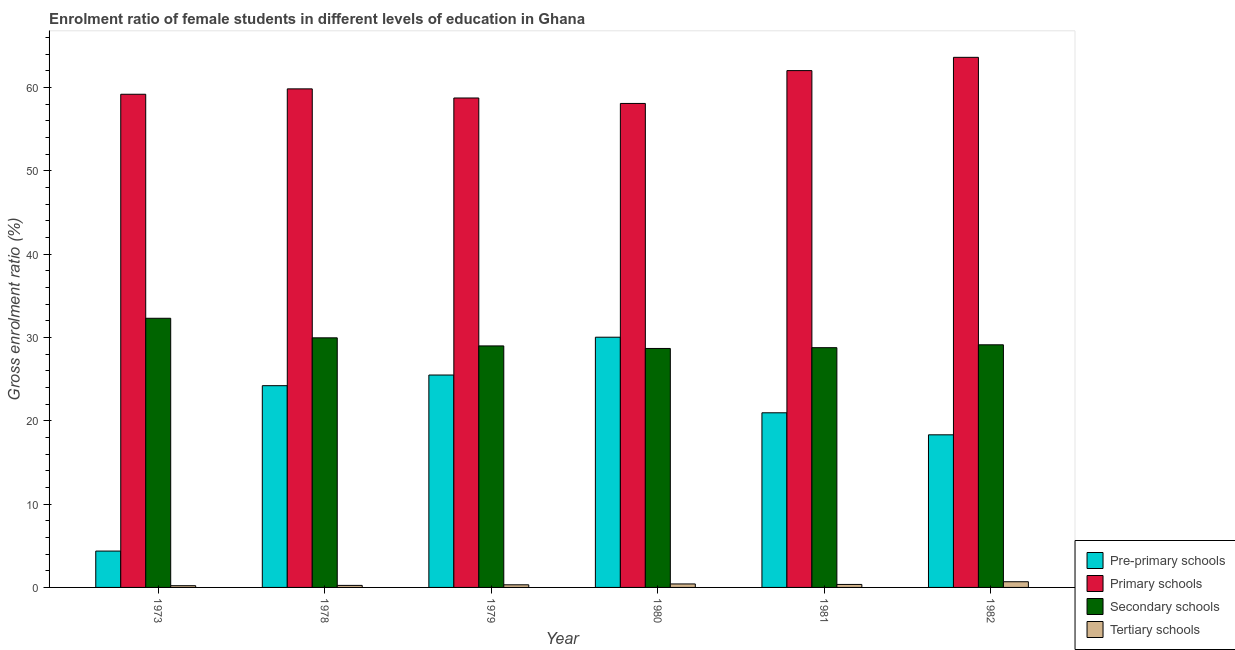Are the number of bars on each tick of the X-axis equal?
Keep it short and to the point. Yes. How many bars are there on the 5th tick from the left?
Offer a terse response. 4. What is the label of the 2nd group of bars from the left?
Provide a short and direct response. 1978. In how many cases, is the number of bars for a given year not equal to the number of legend labels?
Your answer should be very brief. 0. What is the gross enrolment ratio(male) in tertiary schools in 1980?
Your answer should be compact. 0.42. Across all years, what is the maximum gross enrolment ratio(male) in secondary schools?
Provide a succinct answer. 32.31. Across all years, what is the minimum gross enrolment ratio(male) in secondary schools?
Offer a terse response. 28.69. In which year was the gross enrolment ratio(male) in secondary schools maximum?
Give a very brief answer. 1973. In which year was the gross enrolment ratio(male) in pre-primary schools minimum?
Your response must be concise. 1973. What is the total gross enrolment ratio(male) in tertiary schools in the graph?
Make the answer very short. 2.23. What is the difference between the gross enrolment ratio(male) in secondary schools in 1973 and that in 1978?
Make the answer very short. 2.35. What is the difference between the gross enrolment ratio(male) in primary schools in 1982 and the gross enrolment ratio(male) in secondary schools in 1980?
Make the answer very short. 5.54. What is the average gross enrolment ratio(male) in primary schools per year?
Offer a terse response. 60.26. In the year 1982, what is the difference between the gross enrolment ratio(male) in pre-primary schools and gross enrolment ratio(male) in tertiary schools?
Provide a succinct answer. 0. In how many years, is the gross enrolment ratio(male) in primary schools greater than 14 %?
Your answer should be very brief. 6. What is the ratio of the gross enrolment ratio(male) in primary schools in 1973 to that in 1981?
Ensure brevity in your answer.  0.95. Is the gross enrolment ratio(male) in secondary schools in 1973 less than that in 1981?
Provide a short and direct response. No. Is the difference between the gross enrolment ratio(male) in pre-primary schools in 1973 and 1979 greater than the difference between the gross enrolment ratio(male) in tertiary schools in 1973 and 1979?
Keep it short and to the point. No. What is the difference between the highest and the second highest gross enrolment ratio(male) in tertiary schools?
Provide a succinct answer. 0.26. What is the difference between the highest and the lowest gross enrolment ratio(male) in primary schools?
Keep it short and to the point. 5.54. Is it the case that in every year, the sum of the gross enrolment ratio(male) in tertiary schools and gross enrolment ratio(male) in secondary schools is greater than the sum of gross enrolment ratio(male) in pre-primary schools and gross enrolment ratio(male) in primary schools?
Provide a short and direct response. No. What does the 4th bar from the left in 1979 represents?
Your answer should be very brief. Tertiary schools. What does the 2nd bar from the right in 1981 represents?
Ensure brevity in your answer.  Secondary schools. Is it the case that in every year, the sum of the gross enrolment ratio(male) in pre-primary schools and gross enrolment ratio(male) in primary schools is greater than the gross enrolment ratio(male) in secondary schools?
Keep it short and to the point. Yes. How many bars are there?
Ensure brevity in your answer.  24. Are all the bars in the graph horizontal?
Your response must be concise. No. How many years are there in the graph?
Provide a short and direct response. 6. Are the values on the major ticks of Y-axis written in scientific E-notation?
Offer a very short reply. No. Does the graph contain grids?
Provide a succinct answer. No. Where does the legend appear in the graph?
Ensure brevity in your answer.  Bottom right. How many legend labels are there?
Offer a very short reply. 4. How are the legend labels stacked?
Provide a succinct answer. Vertical. What is the title of the graph?
Keep it short and to the point. Enrolment ratio of female students in different levels of education in Ghana. What is the label or title of the X-axis?
Make the answer very short. Year. What is the Gross enrolment ratio (%) of Pre-primary schools in 1973?
Make the answer very short. 4.36. What is the Gross enrolment ratio (%) in Primary schools in 1973?
Offer a very short reply. 59.2. What is the Gross enrolment ratio (%) in Secondary schools in 1973?
Keep it short and to the point. 32.31. What is the Gross enrolment ratio (%) in Tertiary schools in 1973?
Your answer should be very brief. 0.21. What is the Gross enrolment ratio (%) in Pre-primary schools in 1978?
Keep it short and to the point. 24.22. What is the Gross enrolment ratio (%) in Primary schools in 1978?
Your answer should be very brief. 59.85. What is the Gross enrolment ratio (%) of Secondary schools in 1978?
Your answer should be compact. 29.96. What is the Gross enrolment ratio (%) in Tertiary schools in 1978?
Make the answer very short. 0.24. What is the Gross enrolment ratio (%) of Pre-primary schools in 1979?
Make the answer very short. 25.5. What is the Gross enrolment ratio (%) of Primary schools in 1979?
Offer a very short reply. 58.75. What is the Gross enrolment ratio (%) of Secondary schools in 1979?
Offer a very short reply. 28.99. What is the Gross enrolment ratio (%) of Tertiary schools in 1979?
Your answer should be compact. 0.32. What is the Gross enrolment ratio (%) of Pre-primary schools in 1980?
Provide a short and direct response. 30.04. What is the Gross enrolment ratio (%) of Primary schools in 1980?
Keep it short and to the point. 58.1. What is the Gross enrolment ratio (%) of Secondary schools in 1980?
Ensure brevity in your answer.  28.69. What is the Gross enrolment ratio (%) in Tertiary schools in 1980?
Provide a short and direct response. 0.42. What is the Gross enrolment ratio (%) in Pre-primary schools in 1981?
Provide a succinct answer. 20.96. What is the Gross enrolment ratio (%) in Primary schools in 1981?
Offer a very short reply. 62.04. What is the Gross enrolment ratio (%) in Secondary schools in 1981?
Ensure brevity in your answer.  28.78. What is the Gross enrolment ratio (%) of Tertiary schools in 1981?
Your answer should be very brief. 0.36. What is the Gross enrolment ratio (%) of Pre-primary schools in 1982?
Offer a terse response. 18.32. What is the Gross enrolment ratio (%) in Primary schools in 1982?
Your response must be concise. 63.64. What is the Gross enrolment ratio (%) in Secondary schools in 1982?
Offer a very short reply. 29.13. What is the Gross enrolment ratio (%) of Tertiary schools in 1982?
Offer a terse response. 0.68. Across all years, what is the maximum Gross enrolment ratio (%) of Pre-primary schools?
Keep it short and to the point. 30.04. Across all years, what is the maximum Gross enrolment ratio (%) of Primary schools?
Offer a very short reply. 63.64. Across all years, what is the maximum Gross enrolment ratio (%) of Secondary schools?
Your answer should be very brief. 32.31. Across all years, what is the maximum Gross enrolment ratio (%) in Tertiary schools?
Ensure brevity in your answer.  0.68. Across all years, what is the minimum Gross enrolment ratio (%) in Pre-primary schools?
Your answer should be compact. 4.36. Across all years, what is the minimum Gross enrolment ratio (%) of Primary schools?
Make the answer very short. 58.1. Across all years, what is the minimum Gross enrolment ratio (%) of Secondary schools?
Offer a terse response. 28.69. Across all years, what is the minimum Gross enrolment ratio (%) in Tertiary schools?
Offer a very short reply. 0.21. What is the total Gross enrolment ratio (%) in Pre-primary schools in the graph?
Make the answer very short. 123.4. What is the total Gross enrolment ratio (%) of Primary schools in the graph?
Your answer should be very brief. 361.59. What is the total Gross enrolment ratio (%) of Secondary schools in the graph?
Your answer should be compact. 177.86. What is the total Gross enrolment ratio (%) in Tertiary schools in the graph?
Offer a very short reply. 2.23. What is the difference between the Gross enrolment ratio (%) in Pre-primary schools in 1973 and that in 1978?
Offer a terse response. -19.85. What is the difference between the Gross enrolment ratio (%) in Primary schools in 1973 and that in 1978?
Give a very brief answer. -0.65. What is the difference between the Gross enrolment ratio (%) of Secondary schools in 1973 and that in 1978?
Provide a succinct answer. 2.35. What is the difference between the Gross enrolment ratio (%) of Tertiary schools in 1973 and that in 1978?
Provide a succinct answer. -0.04. What is the difference between the Gross enrolment ratio (%) in Pre-primary schools in 1973 and that in 1979?
Your answer should be compact. -21.13. What is the difference between the Gross enrolment ratio (%) in Primary schools in 1973 and that in 1979?
Your answer should be compact. 0.45. What is the difference between the Gross enrolment ratio (%) of Secondary schools in 1973 and that in 1979?
Your response must be concise. 3.32. What is the difference between the Gross enrolment ratio (%) of Tertiary schools in 1973 and that in 1979?
Your answer should be compact. -0.11. What is the difference between the Gross enrolment ratio (%) in Pre-primary schools in 1973 and that in 1980?
Your answer should be compact. -25.67. What is the difference between the Gross enrolment ratio (%) of Primary schools in 1973 and that in 1980?
Your answer should be very brief. 1.1. What is the difference between the Gross enrolment ratio (%) in Secondary schools in 1973 and that in 1980?
Ensure brevity in your answer.  3.62. What is the difference between the Gross enrolment ratio (%) in Tertiary schools in 1973 and that in 1980?
Your answer should be very brief. -0.21. What is the difference between the Gross enrolment ratio (%) in Pre-primary schools in 1973 and that in 1981?
Your answer should be compact. -16.6. What is the difference between the Gross enrolment ratio (%) in Primary schools in 1973 and that in 1981?
Give a very brief answer. -2.84. What is the difference between the Gross enrolment ratio (%) of Secondary schools in 1973 and that in 1981?
Your response must be concise. 3.53. What is the difference between the Gross enrolment ratio (%) in Tertiary schools in 1973 and that in 1981?
Keep it short and to the point. -0.15. What is the difference between the Gross enrolment ratio (%) of Pre-primary schools in 1973 and that in 1982?
Your answer should be compact. -13.95. What is the difference between the Gross enrolment ratio (%) of Primary schools in 1973 and that in 1982?
Offer a very short reply. -4.43. What is the difference between the Gross enrolment ratio (%) of Secondary schools in 1973 and that in 1982?
Provide a short and direct response. 3.18. What is the difference between the Gross enrolment ratio (%) in Tertiary schools in 1973 and that in 1982?
Your answer should be compact. -0.47. What is the difference between the Gross enrolment ratio (%) in Pre-primary schools in 1978 and that in 1979?
Provide a short and direct response. -1.28. What is the difference between the Gross enrolment ratio (%) of Primary schools in 1978 and that in 1979?
Make the answer very short. 1.1. What is the difference between the Gross enrolment ratio (%) of Secondary schools in 1978 and that in 1979?
Give a very brief answer. 0.97. What is the difference between the Gross enrolment ratio (%) in Tertiary schools in 1978 and that in 1979?
Provide a short and direct response. -0.07. What is the difference between the Gross enrolment ratio (%) of Pre-primary schools in 1978 and that in 1980?
Ensure brevity in your answer.  -5.82. What is the difference between the Gross enrolment ratio (%) in Primary schools in 1978 and that in 1980?
Provide a succinct answer. 1.75. What is the difference between the Gross enrolment ratio (%) in Secondary schools in 1978 and that in 1980?
Your answer should be very brief. 1.28. What is the difference between the Gross enrolment ratio (%) in Tertiary schools in 1978 and that in 1980?
Your response must be concise. -0.17. What is the difference between the Gross enrolment ratio (%) in Pre-primary schools in 1978 and that in 1981?
Your answer should be very brief. 3.26. What is the difference between the Gross enrolment ratio (%) of Primary schools in 1978 and that in 1981?
Give a very brief answer. -2.19. What is the difference between the Gross enrolment ratio (%) in Secondary schools in 1978 and that in 1981?
Keep it short and to the point. 1.18. What is the difference between the Gross enrolment ratio (%) of Tertiary schools in 1978 and that in 1981?
Offer a terse response. -0.11. What is the difference between the Gross enrolment ratio (%) in Pre-primary schools in 1978 and that in 1982?
Make the answer very short. 5.9. What is the difference between the Gross enrolment ratio (%) of Primary schools in 1978 and that in 1982?
Your answer should be very brief. -3.79. What is the difference between the Gross enrolment ratio (%) of Secondary schools in 1978 and that in 1982?
Your response must be concise. 0.84. What is the difference between the Gross enrolment ratio (%) of Tertiary schools in 1978 and that in 1982?
Your answer should be compact. -0.44. What is the difference between the Gross enrolment ratio (%) of Pre-primary schools in 1979 and that in 1980?
Provide a short and direct response. -4.54. What is the difference between the Gross enrolment ratio (%) of Primary schools in 1979 and that in 1980?
Keep it short and to the point. 0.66. What is the difference between the Gross enrolment ratio (%) in Secondary schools in 1979 and that in 1980?
Offer a terse response. 0.31. What is the difference between the Gross enrolment ratio (%) of Tertiary schools in 1979 and that in 1980?
Your answer should be very brief. -0.1. What is the difference between the Gross enrolment ratio (%) in Pre-primary schools in 1979 and that in 1981?
Keep it short and to the point. 4.53. What is the difference between the Gross enrolment ratio (%) in Primary schools in 1979 and that in 1981?
Provide a succinct answer. -3.29. What is the difference between the Gross enrolment ratio (%) of Secondary schools in 1979 and that in 1981?
Offer a terse response. 0.21. What is the difference between the Gross enrolment ratio (%) in Tertiary schools in 1979 and that in 1981?
Provide a short and direct response. -0.04. What is the difference between the Gross enrolment ratio (%) of Pre-primary schools in 1979 and that in 1982?
Provide a short and direct response. 7.18. What is the difference between the Gross enrolment ratio (%) in Primary schools in 1979 and that in 1982?
Keep it short and to the point. -4.88. What is the difference between the Gross enrolment ratio (%) in Secondary schools in 1979 and that in 1982?
Your response must be concise. -0.13. What is the difference between the Gross enrolment ratio (%) of Tertiary schools in 1979 and that in 1982?
Your answer should be compact. -0.37. What is the difference between the Gross enrolment ratio (%) of Pre-primary schools in 1980 and that in 1981?
Give a very brief answer. 9.07. What is the difference between the Gross enrolment ratio (%) of Primary schools in 1980 and that in 1981?
Provide a short and direct response. -3.94. What is the difference between the Gross enrolment ratio (%) in Secondary schools in 1980 and that in 1981?
Your answer should be compact. -0.09. What is the difference between the Gross enrolment ratio (%) in Tertiary schools in 1980 and that in 1981?
Make the answer very short. 0.06. What is the difference between the Gross enrolment ratio (%) of Pre-primary schools in 1980 and that in 1982?
Offer a terse response. 11.72. What is the difference between the Gross enrolment ratio (%) of Primary schools in 1980 and that in 1982?
Ensure brevity in your answer.  -5.54. What is the difference between the Gross enrolment ratio (%) of Secondary schools in 1980 and that in 1982?
Keep it short and to the point. -0.44. What is the difference between the Gross enrolment ratio (%) in Tertiary schools in 1980 and that in 1982?
Keep it short and to the point. -0.26. What is the difference between the Gross enrolment ratio (%) in Pre-primary schools in 1981 and that in 1982?
Make the answer very short. 2.64. What is the difference between the Gross enrolment ratio (%) in Primary schools in 1981 and that in 1982?
Provide a succinct answer. -1.59. What is the difference between the Gross enrolment ratio (%) in Secondary schools in 1981 and that in 1982?
Your response must be concise. -0.35. What is the difference between the Gross enrolment ratio (%) in Tertiary schools in 1981 and that in 1982?
Offer a terse response. -0.32. What is the difference between the Gross enrolment ratio (%) in Pre-primary schools in 1973 and the Gross enrolment ratio (%) in Primary schools in 1978?
Give a very brief answer. -55.49. What is the difference between the Gross enrolment ratio (%) in Pre-primary schools in 1973 and the Gross enrolment ratio (%) in Secondary schools in 1978?
Provide a short and direct response. -25.6. What is the difference between the Gross enrolment ratio (%) in Pre-primary schools in 1973 and the Gross enrolment ratio (%) in Tertiary schools in 1978?
Your answer should be very brief. 4.12. What is the difference between the Gross enrolment ratio (%) of Primary schools in 1973 and the Gross enrolment ratio (%) of Secondary schools in 1978?
Your answer should be very brief. 29.24. What is the difference between the Gross enrolment ratio (%) in Primary schools in 1973 and the Gross enrolment ratio (%) in Tertiary schools in 1978?
Your answer should be very brief. 58.96. What is the difference between the Gross enrolment ratio (%) in Secondary schools in 1973 and the Gross enrolment ratio (%) in Tertiary schools in 1978?
Your response must be concise. 32.07. What is the difference between the Gross enrolment ratio (%) in Pre-primary schools in 1973 and the Gross enrolment ratio (%) in Primary schools in 1979?
Make the answer very short. -54.39. What is the difference between the Gross enrolment ratio (%) of Pre-primary schools in 1973 and the Gross enrolment ratio (%) of Secondary schools in 1979?
Your answer should be very brief. -24.63. What is the difference between the Gross enrolment ratio (%) in Pre-primary schools in 1973 and the Gross enrolment ratio (%) in Tertiary schools in 1979?
Your answer should be very brief. 4.05. What is the difference between the Gross enrolment ratio (%) of Primary schools in 1973 and the Gross enrolment ratio (%) of Secondary schools in 1979?
Make the answer very short. 30.21. What is the difference between the Gross enrolment ratio (%) of Primary schools in 1973 and the Gross enrolment ratio (%) of Tertiary schools in 1979?
Offer a very short reply. 58.89. What is the difference between the Gross enrolment ratio (%) in Secondary schools in 1973 and the Gross enrolment ratio (%) in Tertiary schools in 1979?
Keep it short and to the point. 31.99. What is the difference between the Gross enrolment ratio (%) in Pre-primary schools in 1973 and the Gross enrolment ratio (%) in Primary schools in 1980?
Your answer should be compact. -53.73. What is the difference between the Gross enrolment ratio (%) of Pre-primary schools in 1973 and the Gross enrolment ratio (%) of Secondary schools in 1980?
Ensure brevity in your answer.  -24.32. What is the difference between the Gross enrolment ratio (%) of Pre-primary schools in 1973 and the Gross enrolment ratio (%) of Tertiary schools in 1980?
Offer a terse response. 3.95. What is the difference between the Gross enrolment ratio (%) of Primary schools in 1973 and the Gross enrolment ratio (%) of Secondary schools in 1980?
Ensure brevity in your answer.  30.52. What is the difference between the Gross enrolment ratio (%) in Primary schools in 1973 and the Gross enrolment ratio (%) in Tertiary schools in 1980?
Your answer should be very brief. 58.78. What is the difference between the Gross enrolment ratio (%) of Secondary schools in 1973 and the Gross enrolment ratio (%) of Tertiary schools in 1980?
Your answer should be very brief. 31.89. What is the difference between the Gross enrolment ratio (%) in Pre-primary schools in 1973 and the Gross enrolment ratio (%) in Primary schools in 1981?
Offer a terse response. -57.68. What is the difference between the Gross enrolment ratio (%) of Pre-primary schools in 1973 and the Gross enrolment ratio (%) of Secondary schools in 1981?
Your response must be concise. -24.41. What is the difference between the Gross enrolment ratio (%) of Pre-primary schools in 1973 and the Gross enrolment ratio (%) of Tertiary schools in 1981?
Make the answer very short. 4.01. What is the difference between the Gross enrolment ratio (%) of Primary schools in 1973 and the Gross enrolment ratio (%) of Secondary schools in 1981?
Your answer should be very brief. 30.42. What is the difference between the Gross enrolment ratio (%) in Primary schools in 1973 and the Gross enrolment ratio (%) in Tertiary schools in 1981?
Your answer should be compact. 58.84. What is the difference between the Gross enrolment ratio (%) in Secondary schools in 1973 and the Gross enrolment ratio (%) in Tertiary schools in 1981?
Your answer should be compact. 31.95. What is the difference between the Gross enrolment ratio (%) of Pre-primary schools in 1973 and the Gross enrolment ratio (%) of Primary schools in 1982?
Offer a terse response. -59.27. What is the difference between the Gross enrolment ratio (%) in Pre-primary schools in 1973 and the Gross enrolment ratio (%) in Secondary schools in 1982?
Your answer should be very brief. -24.76. What is the difference between the Gross enrolment ratio (%) in Pre-primary schools in 1973 and the Gross enrolment ratio (%) in Tertiary schools in 1982?
Provide a succinct answer. 3.68. What is the difference between the Gross enrolment ratio (%) of Primary schools in 1973 and the Gross enrolment ratio (%) of Secondary schools in 1982?
Make the answer very short. 30.08. What is the difference between the Gross enrolment ratio (%) of Primary schools in 1973 and the Gross enrolment ratio (%) of Tertiary schools in 1982?
Provide a succinct answer. 58.52. What is the difference between the Gross enrolment ratio (%) of Secondary schools in 1973 and the Gross enrolment ratio (%) of Tertiary schools in 1982?
Your response must be concise. 31.63. What is the difference between the Gross enrolment ratio (%) of Pre-primary schools in 1978 and the Gross enrolment ratio (%) of Primary schools in 1979?
Your answer should be very brief. -34.54. What is the difference between the Gross enrolment ratio (%) in Pre-primary schools in 1978 and the Gross enrolment ratio (%) in Secondary schools in 1979?
Ensure brevity in your answer.  -4.77. What is the difference between the Gross enrolment ratio (%) in Pre-primary schools in 1978 and the Gross enrolment ratio (%) in Tertiary schools in 1979?
Provide a short and direct response. 23.9. What is the difference between the Gross enrolment ratio (%) in Primary schools in 1978 and the Gross enrolment ratio (%) in Secondary schools in 1979?
Your answer should be compact. 30.86. What is the difference between the Gross enrolment ratio (%) in Primary schools in 1978 and the Gross enrolment ratio (%) in Tertiary schools in 1979?
Keep it short and to the point. 59.53. What is the difference between the Gross enrolment ratio (%) of Secondary schools in 1978 and the Gross enrolment ratio (%) of Tertiary schools in 1979?
Provide a short and direct response. 29.65. What is the difference between the Gross enrolment ratio (%) of Pre-primary schools in 1978 and the Gross enrolment ratio (%) of Primary schools in 1980?
Give a very brief answer. -33.88. What is the difference between the Gross enrolment ratio (%) of Pre-primary schools in 1978 and the Gross enrolment ratio (%) of Secondary schools in 1980?
Give a very brief answer. -4.47. What is the difference between the Gross enrolment ratio (%) of Pre-primary schools in 1978 and the Gross enrolment ratio (%) of Tertiary schools in 1980?
Offer a very short reply. 23.8. What is the difference between the Gross enrolment ratio (%) of Primary schools in 1978 and the Gross enrolment ratio (%) of Secondary schools in 1980?
Keep it short and to the point. 31.16. What is the difference between the Gross enrolment ratio (%) in Primary schools in 1978 and the Gross enrolment ratio (%) in Tertiary schools in 1980?
Ensure brevity in your answer.  59.43. What is the difference between the Gross enrolment ratio (%) in Secondary schools in 1978 and the Gross enrolment ratio (%) in Tertiary schools in 1980?
Keep it short and to the point. 29.54. What is the difference between the Gross enrolment ratio (%) in Pre-primary schools in 1978 and the Gross enrolment ratio (%) in Primary schools in 1981?
Make the answer very short. -37.82. What is the difference between the Gross enrolment ratio (%) of Pre-primary schools in 1978 and the Gross enrolment ratio (%) of Secondary schools in 1981?
Provide a short and direct response. -4.56. What is the difference between the Gross enrolment ratio (%) of Pre-primary schools in 1978 and the Gross enrolment ratio (%) of Tertiary schools in 1981?
Keep it short and to the point. 23.86. What is the difference between the Gross enrolment ratio (%) in Primary schools in 1978 and the Gross enrolment ratio (%) in Secondary schools in 1981?
Keep it short and to the point. 31.07. What is the difference between the Gross enrolment ratio (%) of Primary schools in 1978 and the Gross enrolment ratio (%) of Tertiary schools in 1981?
Offer a terse response. 59.49. What is the difference between the Gross enrolment ratio (%) in Secondary schools in 1978 and the Gross enrolment ratio (%) in Tertiary schools in 1981?
Your answer should be very brief. 29.6. What is the difference between the Gross enrolment ratio (%) in Pre-primary schools in 1978 and the Gross enrolment ratio (%) in Primary schools in 1982?
Make the answer very short. -39.42. What is the difference between the Gross enrolment ratio (%) of Pre-primary schools in 1978 and the Gross enrolment ratio (%) of Secondary schools in 1982?
Offer a terse response. -4.91. What is the difference between the Gross enrolment ratio (%) of Pre-primary schools in 1978 and the Gross enrolment ratio (%) of Tertiary schools in 1982?
Ensure brevity in your answer.  23.54. What is the difference between the Gross enrolment ratio (%) of Primary schools in 1978 and the Gross enrolment ratio (%) of Secondary schools in 1982?
Ensure brevity in your answer.  30.72. What is the difference between the Gross enrolment ratio (%) in Primary schools in 1978 and the Gross enrolment ratio (%) in Tertiary schools in 1982?
Your response must be concise. 59.17. What is the difference between the Gross enrolment ratio (%) in Secondary schools in 1978 and the Gross enrolment ratio (%) in Tertiary schools in 1982?
Provide a short and direct response. 29.28. What is the difference between the Gross enrolment ratio (%) of Pre-primary schools in 1979 and the Gross enrolment ratio (%) of Primary schools in 1980?
Your answer should be very brief. -32.6. What is the difference between the Gross enrolment ratio (%) of Pre-primary schools in 1979 and the Gross enrolment ratio (%) of Secondary schools in 1980?
Provide a succinct answer. -3.19. What is the difference between the Gross enrolment ratio (%) in Pre-primary schools in 1979 and the Gross enrolment ratio (%) in Tertiary schools in 1980?
Ensure brevity in your answer.  25.08. What is the difference between the Gross enrolment ratio (%) of Primary schools in 1979 and the Gross enrolment ratio (%) of Secondary schools in 1980?
Provide a short and direct response. 30.07. What is the difference between the Gross enrolment ratio (%) of Primary schools in 1979 and the Gross enrolment ratio (%) of Tertiary schools in 1980?
Give a very brief answer. 58.34. What is the difference between the Gross enrolment ratio (%) of Secondary schools in 1979 and the Gross enrolment ratio (%) of Tertiary schools in 1980?
Your answer should be compact. 28.57. What is the difference between the Gross enrolment ratio (%) in Pre-primary schools in 1979 and the Gross enrolment ratio (%) in Primary schools in 1981?
Your answer should be compact. -36.54. What is the difference between the Gross enrolment ratio (%) in Pre-primary schools in 1979 and the Gross enrolment ratio (%) in Secondary schools in 1981?
Keep it short and to the point. -3.28. What is the difference between the Gross enrolment ratio (%) of Pre-primary schools in 1979 and the Gross enrolment ratio (%) of Tertiary schools in 1981?
Your answer should be very brief. 25.14. What is the difference between the Gross enrolment ratio (%) of Primary schools in 1979 and the Gross enrolment ratio (%) of Secondary schools in 1981?
Your answer should be very brief. 29.97. What is the difference between the Gross enrolment ratio (%) of Primary schools in 1979 and the Gross enrolment ratio (%) of Tertiary schools in 1981?
Your answer should be very brief. 58.4. What is the difference between the Gross enrolment ratio (%) of Secondary schools in 1979 and the Gross enrolment ratio (%) of Tertiary schools in 1981?
Offer a very short reply. 28.63. What is the difference between the Gross enrolment ratio (%) in Pre-primary schools in 1979 and the Gross enrolment ratio (%) in Primary schools in 1982?
Give a very brief answer. -38.14. What is the difference between the Gross enrolment ratio (%) in Pre-primary schools in 1979 and the Gross enrolment ratio (%) in Secondary schools in 1982?
Keep it short and to the point. -3.63. What is the difference between the Gross enrolment ratio (%) of Pre-primary schools in 1979 and the Gross enrolment ratio (%) of Tertiary schools in 1982?
Your answer should be compact. 24.82. What is the difference between the Gross enrolment ratio (%) of Primary schools in 1979 and the Gross enrolment ratio (%) of Secondary schools in 1982?
Offer a very short reply. 29.63. What is the difference between the Gross enrolment ratio (%) of Primary schools in 1979 and the Gross enrolment ratio (%) of Tertiary schools in 1982?
Offer a terse response. 58.07. What is the difference between the Gross enrolment ratio (%) of Secondary schools in 1979 and the Gross enrolment ratio (%) of Tertiary schools in 1982?
Keep it short and to the point. 28.31. What is the difference between the Gross enrolment ratio (%) of Pre-primary schools in 1980 and the Gross enrolment ratio (%) of Primary schools in 1981?
Ensure brevity in your answer.  -32.01. What is the difference between the Gross enrolment ratio (%) of Pre-primary schools in 1980 and the Gross enrolment ratio (%) of Secondary schools in 1981?
Your answer should be compact. 1.26. What is the difference between the Gross enrolment ratio (%) in Pre-primary schools in 1980 and the Gross enrolment ratio (%) in Tertiary schools in 1981?
Make the answer very short. 29.68. What is the difference between the Gross enrolment ratio (%) in Primary schools in 1980 and the Gross enrolment ratio (%) in Secondary schools in 1981?
Give a very brief answer. 29.32. What is the difference between the Gross enrolment ratio (%) of Primary schools in 1980 and the Gross enrolment ratio (%) of Tertiary schools in 1981?
Provide a succinct answer. 57.74. What is the difference between the Gross enrolment ratio (%) of Secondary schools in 1980 and the Gross enrolment ratio (%) of Tertiary schools in 1981?
Your answer should be very brief. 28.33. What is the difference between the Gross enrolment ratio (%) of Pre-primary schools in 1980 and the Gross enrolment ratio (%) of Primary schools in 1982?
Offer a very short reply. -33.6. What is the difference between the Gross enrolment ratio (%) in Pre-primary schools in 1980 and the Gross enrolment ratio (%) in Secondary schools in 1982?
Provide a succinct answer. 0.91. What is the difference between the Gross enrolment ratio (%) in Pre-primary schools in 1980 and the Gross enrolment ratio (%) in Tertiary schools in 1982?
Your answer should be compact. 29.35. What is the difference between the Gross enrolment ratio (%) of Primary schools in 1980 and the Gross enrolment ratio (%) of Secondary schools in 1982?
Keep it short and to the point. 28.97. What is the difference between the Gross enrolment ratio (%) in Primary schools in 1980 and the Gross enrolment ratio (%) in Tertiary schools in 1982?
Keep it short and to the point. 57.42. What is the difference between the Gross enrolment ratio (%) in Secondary schools in 1980 and the Gross enrolment ratio (%) in Tertiary schools in 1982?
Ensure brevity in your answer.  28. What is the difference between the Gross enrolment ratio (%) in Pre-primary schools in 1981 and the Gross enrolment ratio (%) in Primary schools in 1982?
Offer a terse response. -42.67. What is the difference between the Gross enrolment ratio (%) in Pre-primary schools in 1981 and the Gross enrolment ratio (%) in Secondary schools in 1982?
Your answer should be very brief. -8.16. What is the difference between the Gross enrolment ratio (%) of Pre-primary schools in 1981 and the Gross enrolment ratio (%) of Tertiary schools in 1982?
Your answer should be very brief. 20.28. What is the difference between the Gross enrolment ratio (%) of Primary schools in 1981 and the Gross enrolment ratio (%) of Secondary schools in 1982?
Your answer should be very brief. 32.92. What is the difference between the Gross enrolment ratio (%) of Primary schools in 1981 and the Gross enrolment ratio (%) of Tertiary schools in 1982?
Your answer should be very brief. 61.36. What is the difference between the Gross enrolment ratio (%) of Secondary schools in 1981 and the Gross enrolment ratio (%) of Tertiary schools in 1982?
Make the answer very short. 28.1. What is the average Gross enrolment ratio (%) in Pre-primary schools per year?
Keep it short and to the point. 20.57. What is the average Gross enrolment ratio (%) of Primary schools per year?
Provide a short and direct response. 60.26. What is the average Gross enrolment ratio (%) of Secondary schools per year?
Give a very brief answer. 29.64. What is the average Gross enrolment ratio (%) of Tertiary schools per year?
Offer a very short reply. 0.37. In the year 1973, what is the difference between the Gross enrolment ratio (%) in Pre-primary schools and Gross enrolment ratio (%) in Primary schools?
Your answer should be very brief. -54.84. In the year 1973, what is the difference between the Gross enrolment ratio (%) of Pre-primary schools and Gross enrolment ratio (%) of Secondary schools?
Your answer should be compact. -27.95. In the year 1973, what is the difference between the Gross enrolment ratio (%) in Pre-primary schools and Gross enrolment ratio (%) in Tertiary schools?
Provide a short and direct response. 4.16. In the year 1973, what is the difference between the Gross enrolment ratio (%) in Primary schools and Gross enrolment ratio (%) in Secondary schools?
Offer a terse response. 26.89. In the year 1973, what is the difference between the Gross enrolment ratio (%) in Primary schools and Gross enrolment ratio (%) in Tertiary schools?
Provide a succinct answer. 59. In the year 1973, what is the difference between the Gross enrolment ratio (%) of Secondary schools and Gross enrolment ratio (%) of Tertiary schools?
Offer a very short reply. 32.1. In the year 1978, what is the difference between the Gross enrolment ratio (%) of Pre-primary schools and Gross enrolment ratio (%) of Primary schools?
Keep it short and to the point. -35.63. In the year 1978, what is the difference between the Gross enrolment ratio (%) in Pre-primary schools and Gross enrolment ratio (%) in Secondary schools?
Offer a very short reply. -5.74. In the year 1978, what is the difference between the Gross enrolment ratio (%) in Pre-primary schools and Gross enrolment ratio (%) in Tertiary schools?
Make the answer very short. 23.98. In the year 1978, what is the difference between the Gross enrolment ratio (%) of Primary schools and Gross enrolment ratio (%) of Secondary schools?
Ensure brevity in your answer.  29.89. In the year 1978, what is the difference between the Gross enrolment ratio (%) in Primary schools and Gross enrolment ratio (%) in Tertiary schools?
Provide a short and direct response. 59.61. In the year 1978, what is the difference between the Gross enrolment ratio (%) of Secondary schools and Gross enrolment ratio (%) of Tertiary schools?
Provide a short and direct response. 29.72. In the year 1979, what is the difference between the Gross enrolment ratio (%) of Pre-primary schools and Gross enrolment ratio (%) of Primary schools?
Provide a short and direct response. -33.26. In the year 1979, what is the difference between the Gross enrolment ratio (%) of Pre-primary schools and Gross enrolment ratio (%) of Secondary schools?
Ensure brevity in your answer.  -3.49. In the year 1979, what is the difference between the Gross enrolment ratio (%) in Pre-primary schools and Gross enrolment ratio (%) in Tertiary schools?
Provide a short and direct response. 25.18. In the year 1979, what is the difference between the Gross enrolment ratio (%) of Primary schools and Gross enrolment ratio (%) of Secondary schools?
Offer a terse response. 29.76. In the year 1979, what is the difference between the Gross enrolment ratio (%) of Primary schools and Gross enrolment ratio (%) of Tertiary schools?
Offer a terse response. 58.44. In the year 1979, what is the difference between the Gross enrolment ratio (%) in Secondary schools and Gross enrolment ratio (%) in Tertiary schools?
Your answer should be compact. 28.68. In the year 1980, what is the difference between the Gross enrolment ratio (%) in Pre-primary schools and Gross enrolment ratio (%) in Primary schools?
Make the answer very short. -28.06. In the year 1980, what is the difference between the Gross enrolment ratio (%) of Pre-primary schools and Gross enrolment ratio (%) of Secondary schools?
Keep it short and to the point. 1.35. In the year 1980, what is the difference between the Gross enrolment ratio (%) in Pre-primary schools and Gross enrolment ratio (%) in Tertiary schools?
Your response must be concise. 29.62. In the year 1980, what is the difference between the Gross enrolment ratio (%) in Primary schools and Gross enrolment ratio (%) in Secondary schools?
Your answer should be compact. 29.41. In the year 1980, what is the difference between the Gross enrolment ratio (%) in Primary schools and Gross enrolment ratio (%) in Tertiary schools?
Offer a terse response. 57.68. In the year 1980, what is the difference between the Gross enrolment ratio (%) in Secondary schools and Gross enrolment ratio (%) in Tertiary schools?
Make the answer very short. 28.27. In the year 1981, what is the difference between the Gross enrolment ratio (%) in Pre-primary schools and Gross enrolment ratio (%) in Primary schools?
Offer a very short reply. -41.08. In the year 1981, what is the difference between the Gross enrolment ratio (%) of Pre-primary schools and Gross enrolment ratio (%) of Secondary schools?
Give a very brief answer. -7.82. In the year 1981, what is the difference between the Gross enrolment ratio (%) in Pre-primary schools and Gross enrolment ratio (%) in Tertiary schools?
Offer a very short reply. 20.6. In the year 1981, what is the difference between the Gross enrolment ratio (%) of Primary schools and Gross enrolment ratio (%) of Secondary schools?
Keep it short and to the point. 33.26. In the year 1981, what is the difference between the Gross enrolment ratio (%) in Primary schools and Gross enrolment ratio (%) in Tertiary schools?
Provide a short and direct response. 61.68. In the year 1981, what is the difference between the Gross enrolment ratio (%) of Secondary schools and Gross enrolment ratio (%) of Tertiary schools?
Your response must be concise. 28.42. In the year 1982, what is the difference between the Gross enrolment ratio (%) in Pre-primary schools and Gross enrolment ratio (%) in Primary schools?
Give a very brief answer. -45.32. In the year 1982, what is the difference between the Gross enrolment ratio (%) of Pre-primary schools and Gross enrolment ratio (%) of Secondary schools?
Your answer should be compact. -10.81. In the year 1982, what is the difference between the Gross enrolment ratio (%) in Pre-primary schools and Gross enrolment ratio (%) in Tertiary schools?
Offer a terse response. 17.64. In the year 1982, what is the difference between the Gross enrolment ratio (%) in Primary schools and Gross enrolment ratio (%) in Secondary schools?
Make the answer very short. 34.51. In the year 1982, what is the difference between the Gross enrolment ratio (%) of Primary schools and Gross enrolment ratio (%) of Tertiary schools?
Your answer should be very brief. 62.95. In the year 1982, what is the difference between the Gross enrolment ratio (%) of Secondary schools and Gross enrolment ratio (%) of Tertiary schools?
Offer a very short reply. 28.44. What is the ratio of the Gross enrolment ratio (%) of Pre-primary schools in 1973 to that in 1978?
Offer a terse response. 0.18. What is the ratio of the Gross enrolment ratio (%) of Primary schools in 1973 to that in 1978?
Provide a short and direct response. 0.99. What is the ratio of the Gross enrolment ratio (%) of Secondary schools in 1973 to that in 1978?
Your answer should be very brief. 1.08. What is the ratio of the Gross enrolment ratio (%) in Tertiary schools in 1973 to that in 1978?
Ensure brevity in your answer.  0.85. What is the ratio of the Gross enrolment ratio (%) in Pre-primary schools in 1973 to that in 1979?
Offer a terse response. 0.17. What is the ratio of the Gross enrolment ratio (%) of Primary schools in 1973 to that in 1979?
Keep it short and to the point. 1.01. What is the ratio of the Gross enrolment ratio (%) of Secondary schools in 1973 to that in 1979?
Give a very brief answer. 1.11. What is the ratio of the Gross enrolment ratio (%) of Tertiary schools in 1973 to that in 1979?
Make the answer very short. 0.66. What is the ratio of the Gross enrolment ratio (%) of Pre-primary schools in 1973 to that in 1980?
Offer a very short reply. 0.15. What is the ratio of the Gross enrolment ratio (%) of Primary schools in 1973 to that in 1980?
Your answer should be very brief. 1.02. What is the ratio of the Gross enrolment ratio (%) in Secondary schools in 1973 to that in 1980?
Ensure brevity in your answer.  1.13. What is the ratio of the Gross enrolment ratio (%) of Tertiary schools in 1973 to that in 1980?
Give a very brief answer. 0.5. What is the ratio of the Gross enrolment ratio (%) in Pre-primary schools in 1973 to that in 1981?
Your answer should be very brief. 0.21. What is the ratio of the Gross enrolment ratio (%) in Primary schools in 1973 to that in 1981?
Provide a succinct answer. 0.95. What is the ratio of the Gross enrolment ratio (%) of Secondary schools in 1973 to that in 1981?
Ensure brevity in your answer.  1.12. What is the ratio of the Gross enrolment ratio (%) of Tertiary schools in 1973 to that in 1981?
Keep it short and to the point. 0.58. What is the ratio of the Gross enrolment ratio (%) of Pre-primary schools in 1973 to that in 1982?
Provide a short and direct response. 0.24. What is the ratio of the Gross enrolment ratio (%) of Primary schools in 1973 to that in 1982?
Your answer should be very brief. 0.93. What is the ratio of the Gross enrolment ratio (%) in Secondary schools in 1973 to that in 1982?
Offer a very short reply. 1.11. What is the ratio of the Gross enrolment ratio (%) in Tertiary schools in 1973 to that in 1982?
Offer a very short reply. 0.3. What is the ratio of the Gross enrolment ratio (%) of Pre-primary schools in 1978 to that in 1979?
Make the answer very short. 0.95. What is the ratio of the Gross enrolment ratio (%) in Primary schools in 1978 to that in 1979?
Your answer should be compact. 1.02. What is the ratio of the Gross enrolment ratio (%) of Secondary schools in 1978 to that in 1979?
Your answer should be compact. 1.03. What is the ratio of the Gross enrolment ratio (%) in Tertiary schools in 1978 to that in 1979?
Your answer should be compact. 0.77. What is the ratio of the Gross enrolment ratio (%) in Pre-primary schools in 1978 to that in 1980?
Your response must be concise. 0.81. What is the ratio of the Gross enrolment ratio (%) of Primary schools in 1978 to that in 1980?
Provide a succinct answer. 1.03. What is the ratio of the Gross enrolment ratio (%) of Secondary schools in 1978 to that in 1980?
Give a very brief answer. 1.04. What is the ratio of the Gross enrolment ratio (%) in Tertiary schools in 1978 to that in 1980?
Keep it short and to the point. 0.58. What is the ratio of the Gross enrolment ratio (%) in Pre-primary schools in 1978 to that in 1981?
Your response must be concise. 1.16. What is the ratio of the Gross enrolment ratio (%) in Primary schools in 1978 to that in 1981?
Keep it short and to the point. 0.96. What is the ratio of the Gross enrolment ratio (%) of Secondary schools in 1978 to that in 1981?
Ensure brevity in your answer.  1.04. What is the ratio of the Gross enrolment ratio (%) of Tertiary schools in 1978 to that in 1981?
Your answer should be very brief. 0.68. What is the ratio of the Gross enrolment ratio (%) in Pre-primary schools in 1978 to that in 1982?
Offer a very short reply. 1.32. What is the ratio of the Gross enrolment ratio (%) in Primary schools in 1978 to that in 1982?
Your response must be concise. 0.94. What is the ratio of the Gross enrolment ratio (%) of Secondary schools in 1978 to that in 1982?
Ensure brevity in your answer.  1.03. What is the ratio of the Gross enrolment ratio (%) in Tertiary schools in 1978 to that in 1982?
Offer a terse response. 0.36. What is the ratio of the Gross enrolment ratio (%) of Pre-primary schools in 1979 to that in 1980?
Provide a succinct answer. 0.85. What is the ratio of the Gross enrolment ratio (%) in Primary schools in 1979 to that in 1980?
Your answer should be compact. 1.01. What is the ratio of the Gross enrolment ratio (%) in Secondary schools in 1979 to that in 1980?
Provide a succinct answer. 1.01. What is the ratio of the Gross enrolment ratio (%) in Tertiary schools in 1979 to that in 1980?
Offer a very short reply. 0.75. What is the ratio of the Gross enrolment ratio (%) of Pre-primary schools in 1979 to that in 1981?
Your answer should be very brief. 1.22. What is the ratio of the Gross enrolment ratio (%) in Primary schools in 1979 to that in 1981?
Your response must be concise. 0.95. What is the ratio of the Gross enrolment ratio (%) in Secondary schools in 1979 to that in 1981?
Your answer should be compact. 1.01. What is the ratio of the Gross enrolment ratio (%) in Tertiary schools in 1979 to that in 1981?
Your answer should be compact. 0.88. What is the ratio of the Gross enrolment ratio (%) of Pre-primary schools in 1979 to that in 1982?
Provide a succinct answer. 1.39. What is the ratio of the Gross enrolment ratio (%) in Primary schools in 1979 to that in 1982?
Offer a terse response. 0.92. What is the ratio of the Gross enrolment ratio (%) of Secondary schools in 1979 to that in 1982?
Ensure brevity in your answer.  1. What is the ratio of the Gross enrolment ratio (%) of Tertiary schools in 1979 to that in 1982?
Your answer should be compact. 0.46. What is the ratio of the Gross enrolment ratio (%) in Pre-primary schools in 1980 to that in 1981?
Make the answer very short. 1.43. What is the ratio of the Gross enrolment ratio (%) in Primary schools in 1980 to that in 1981?
Offer a very short reply. 0.94. What is the ratio of the Gross enrolment ratio (%) of Secondary schools in 1980 to that in 1981?
Your response must be concise. 1. What is the ratio of the Gross enrolment ratio (%) in Tertiary schools in 1980 to that in 1981?
Keep it short and to the point. 1.17. What is the ratio of the Gross enrolment ratio (%) in Pre-primary schools in 1980 to that in 1982?
Offer a very short reply. 1.64. What is the ratio of the Gross enrolment ratio (%) of Primary schools in 1980 to that in 1982?
Your response must be concise. 0.91. What is the ratio of the Gross enrolment ratio (%) of Secondary schools in 1980 to that in 1982?
Keep it short and to the point. 0.98. What is the ratio of the Gross enrolment ratio (%) in Tertiary schools in 1980 to that in 1982?
Your answer should be very brief. 0.61. What is the ratio of the Gross enrolment ratio (%) of Pre-primary schools in 1981 to that in 1982?
Your answer should be compact. 1.14. What is the ratio of the Gross enrolment ratio (%) in Secondary schools in 1981 to that in 1982?
Provide a short and direct response. 0.99. What is the ratio of the Gross enrolment ratio (%) in Tertiary schools in 1981 to that in 1982?
Provide a succinct answer. 0.53. What is the difference between the highest and the second highest Gross enrolment ratio (%) of Pre-primary schools?
Offer a very short reply. 4.54. What is the difference between the highest and the second highest Gross enrolment ratio (%) in Primary schools?
Make the answer very short. 1.59. What is the difference between the highest and the second highest Gross enrolment ratio (%) in Secondary schools?
Offer a terse response. 2.35. What is the difference between the highest and the second highest Gross enrolment ratio (%) in Tertiary schools?
Provide a succinct answer. 0.26. What is the difference between the highest and the lowest Gross enrolment ratio (%) of Pre-primary schools?
Offer a terse response. 25.67. What is the difference between the highest and the lowest Gross enrolment ratio (%) of Primary schools?
Your answer should be compact. 5.54. What is the difference between the highest and the lowest Gross enrolment ratio (%) of Secondary schools?
Give a very brief answer. 3.62. What is the difference between the highest and the lowest Gross enrolment ratio (%) in Tertiary schools?
Make the answer very short. 0.47. 